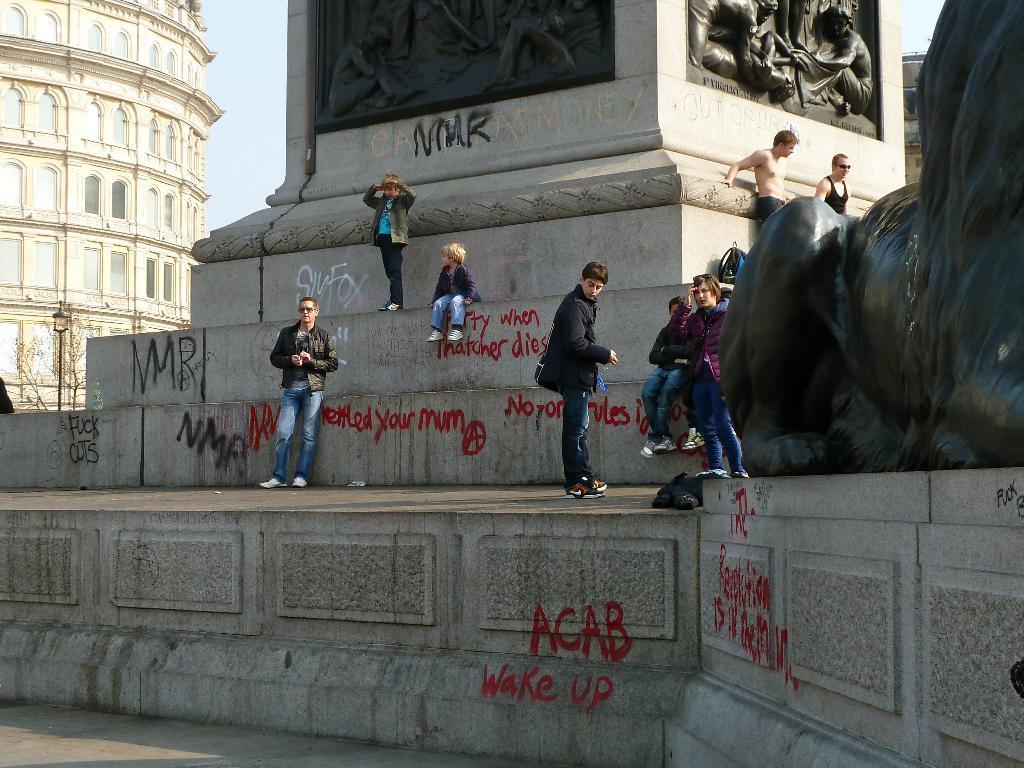Describe this image in one or two sentences. In this image, we can see a building and we can see some sculptures on the wall and there's also some text and there is a statue and a light pole and trees. At the top, there is sky and at the bottom, there is a road. 